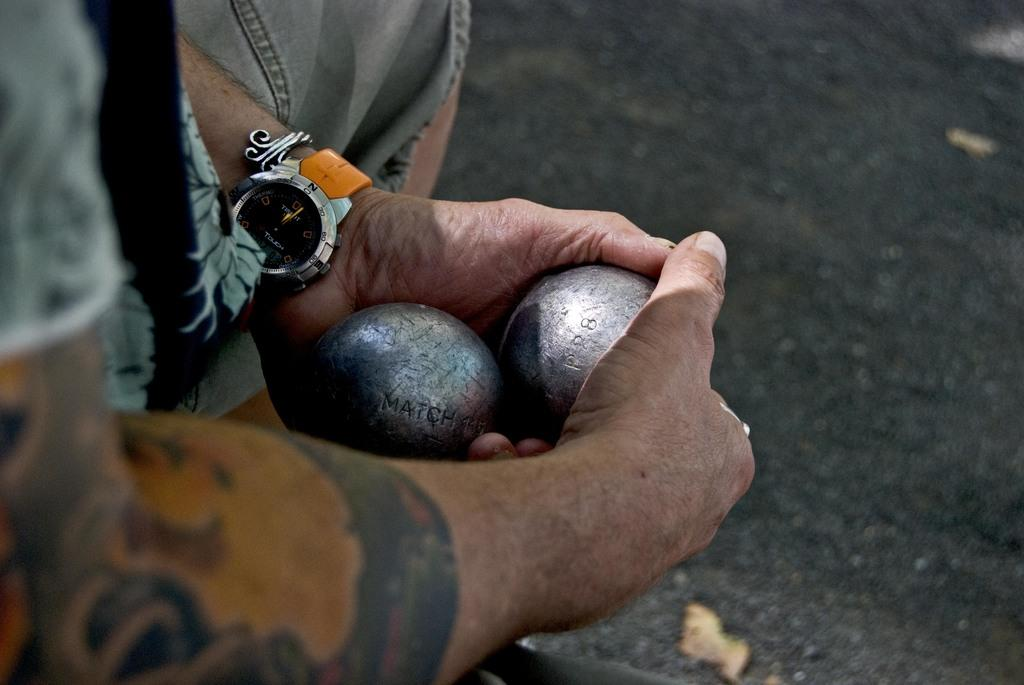Provide a one-sentence caption for the provided image. A man wears a watch with the word "touch" on the face. 